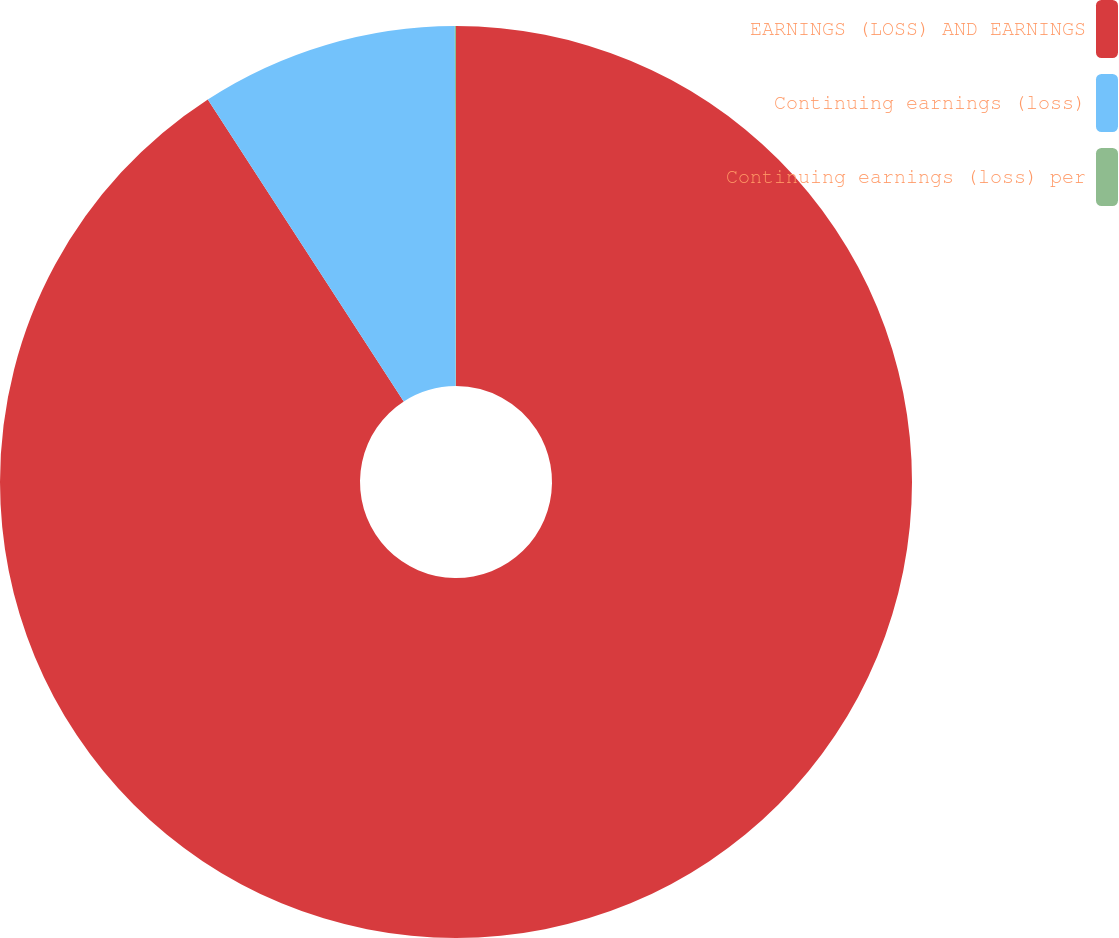<chart> <loc_0><loc_0><loc_500><loc_500><pie_chart><fcel>EARNINGS (LOSS) AND EARNINGS<fcel>Continuing earnings (loss)<fcel>Continuing earnings (loss) per<nl><fcel>90.84%<fcel>9.12%<fcel>0.04%<nl></chart> 